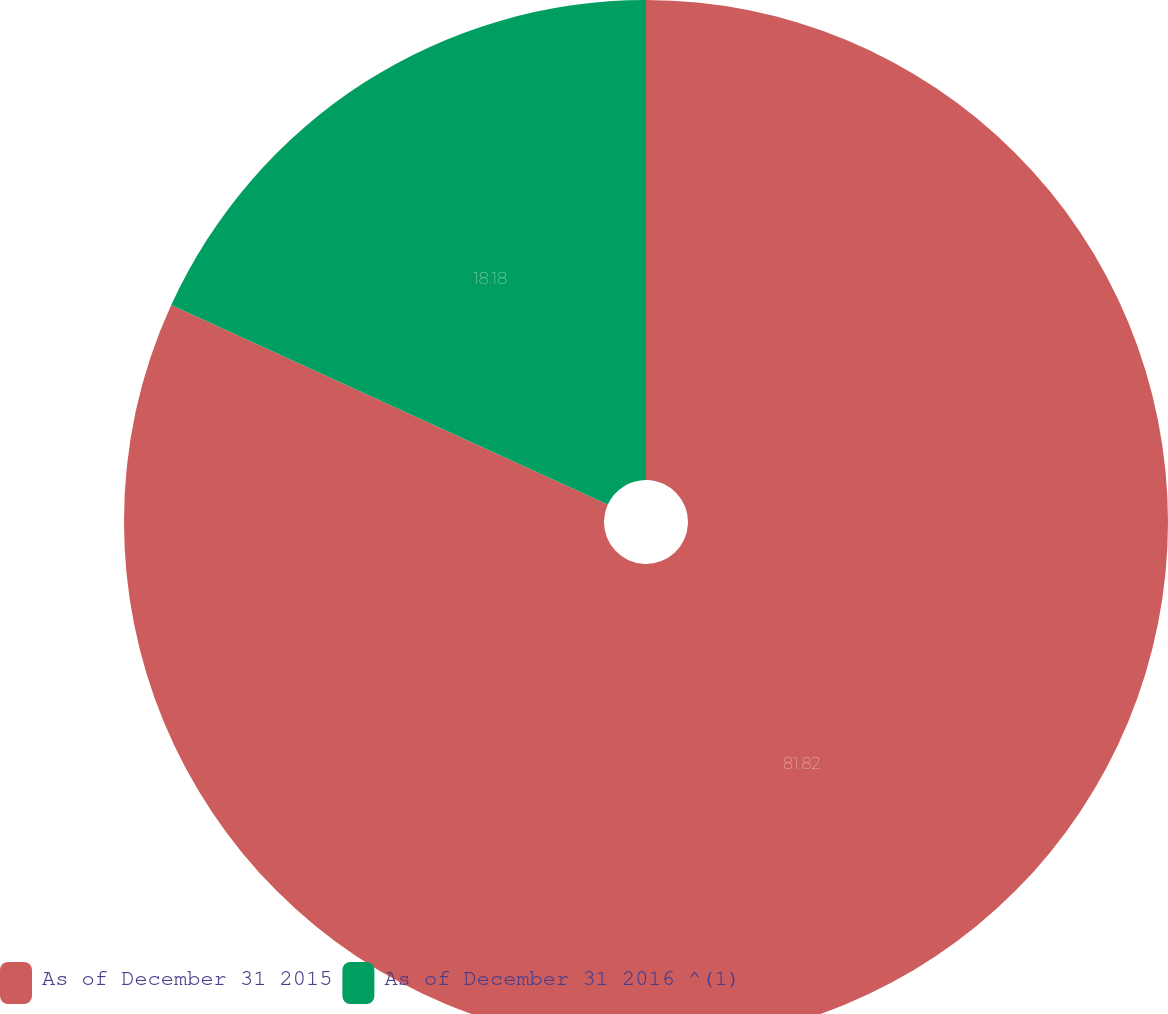Convert chart. <chart><loc_0><loc_0><loc_500><loc_500><pie_chart><fcel>As of December 31 2015<fcel>As of December 31 2016 ^(1)<nl><fcel>81.82%<fcel>18.18%<nl></chart> 